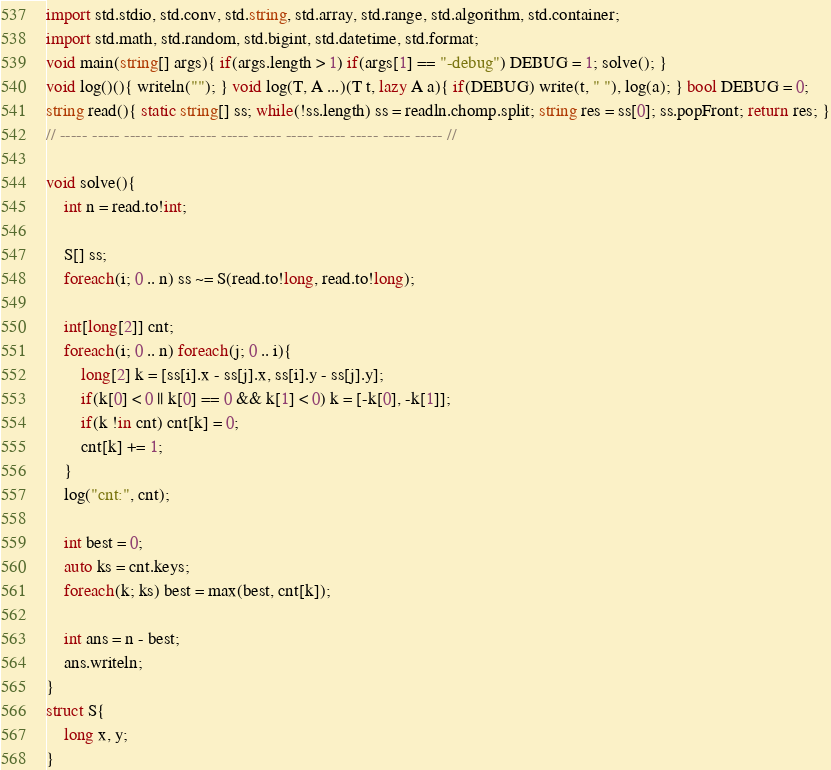<code> <loc_0><loc_0><loc_500><loc_500><_D_>import std.stdio, std.conv, std.string, std.array, std.range, std.algorithm, std.container;
import std.math, std.random, std.bigint, std.datetime, std.format;
void main(string[] args){ if(args.length > 1) if(args[1] == "-debug") DEBUG = 1; solve(); }
void log()(){ writeln(""); } void log(T, A ...)(T t, lazy A a){ if(DEBUG) write(t, " "), log(a); } bool DEBUG = 0; 
string read(){ static string[] ss; while(!ss.length) ss = readln.chomp.split; string res = ss[0]; ss.popFront; return res; }
// ----- ----- ----- ----- ----- ----- ----- ----- ----- ----- ----- ----- //

void solve(){
	int n = read.to!int;
	
	S[] ss;
	foreach(i; 0 .. n) ss ~= S(read.to!long, read.to!long);
	
	int[long[2]] cnt;
	foreach(i; 0 .. n) foreach(j; 0 .. i){
		long[2] k = [ss[i].x - ss[j].x, ss[i].y - ss[j].y];
		if(k[0] < 0 || k[0] == 0 && k[1] < 0) k = [-k[0], -k[1]];
		if(k !in cnt) cnt[k] = 0;
		cnt[k] += 1;
	}
	log("cnt:", cnt);
	
	int best = 0;
	auto ks = cnt.keys;
	foreach(k; ks) best = max(best, cnt[k]);
	
	int ans = n - best;
	ans.writeln;
}
struct S{
	long x, y;
}
</code> 